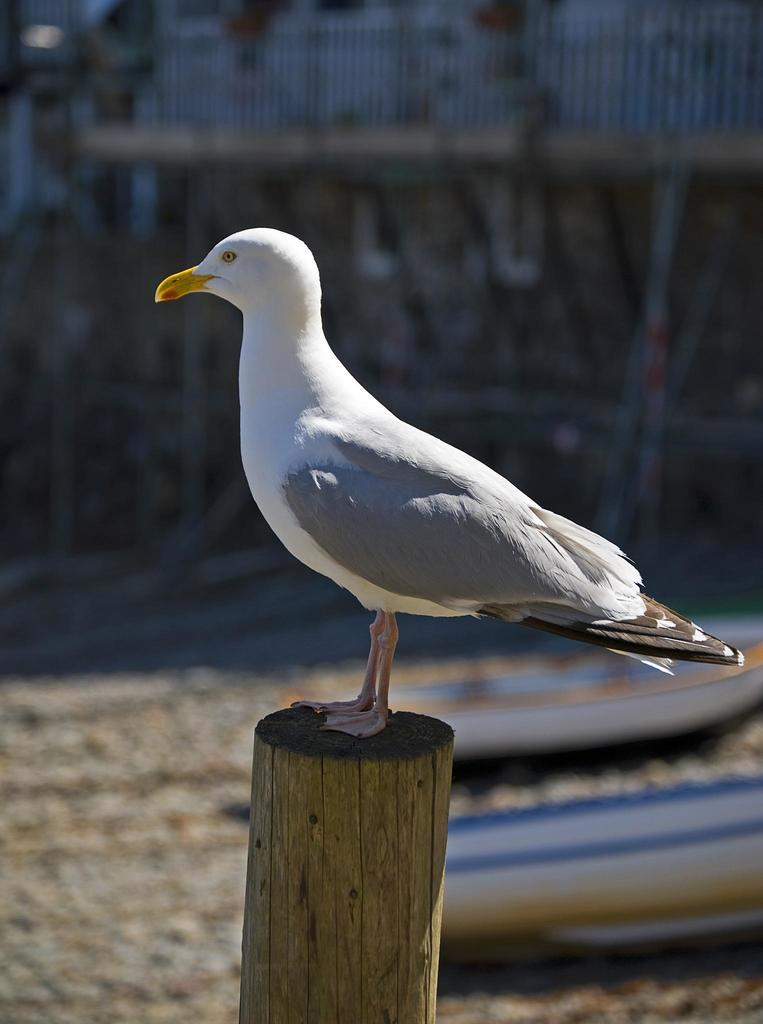What is the main subject of the image? There is a bird standing on a wooden log in the image. What else can be seen in the image besides the bird? There are boats docked on the ground in the image. Can you describe the background of the image? The background of the image is blurred. How many chairs are visible in the image? There are no chairs present in the image. Are there any dinosaurs visible in the image? There are no dinosaurs present in the image. 